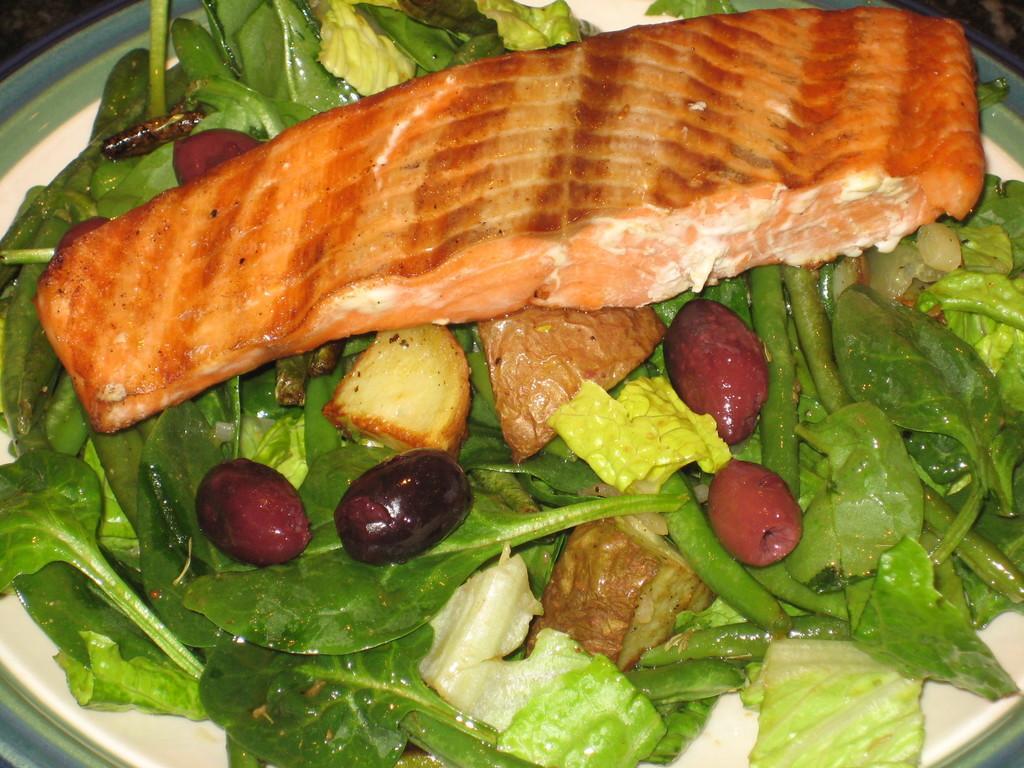In one or two sentences, can you explain what this image depicts? In this plate we can see fry fish, potato pieces, vegetables and other food items. This plate is kept on the table. 